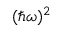<formula> <loc_0><loc_0><loc_500><loc_500>( \hbar { \omega } ) ^ { 2 }</formula> 